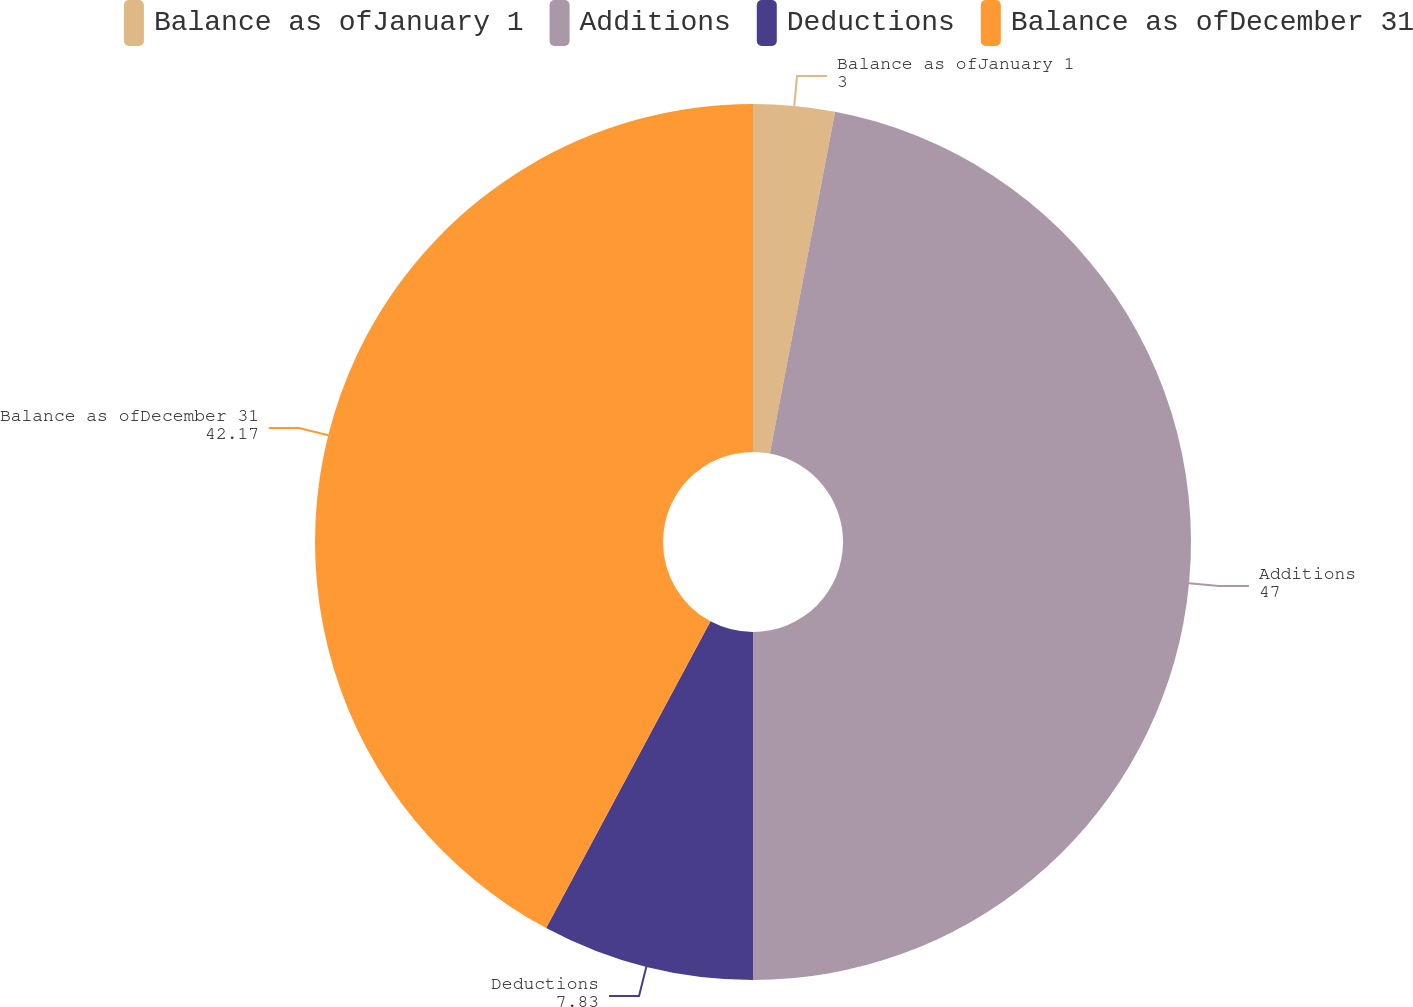Convert chart. <chart><loc_0><loc_0><loc_500><loc_500><pie_chart><fcel>Balance as ofJanuary 1<fcel>Additions<fcel>Deductions<fcel>Balance as ofDecember 31<nl><fcel>3.0%<fcel>47.0%<fcel>7.83%<fcel>42.17%<nl></chart> 